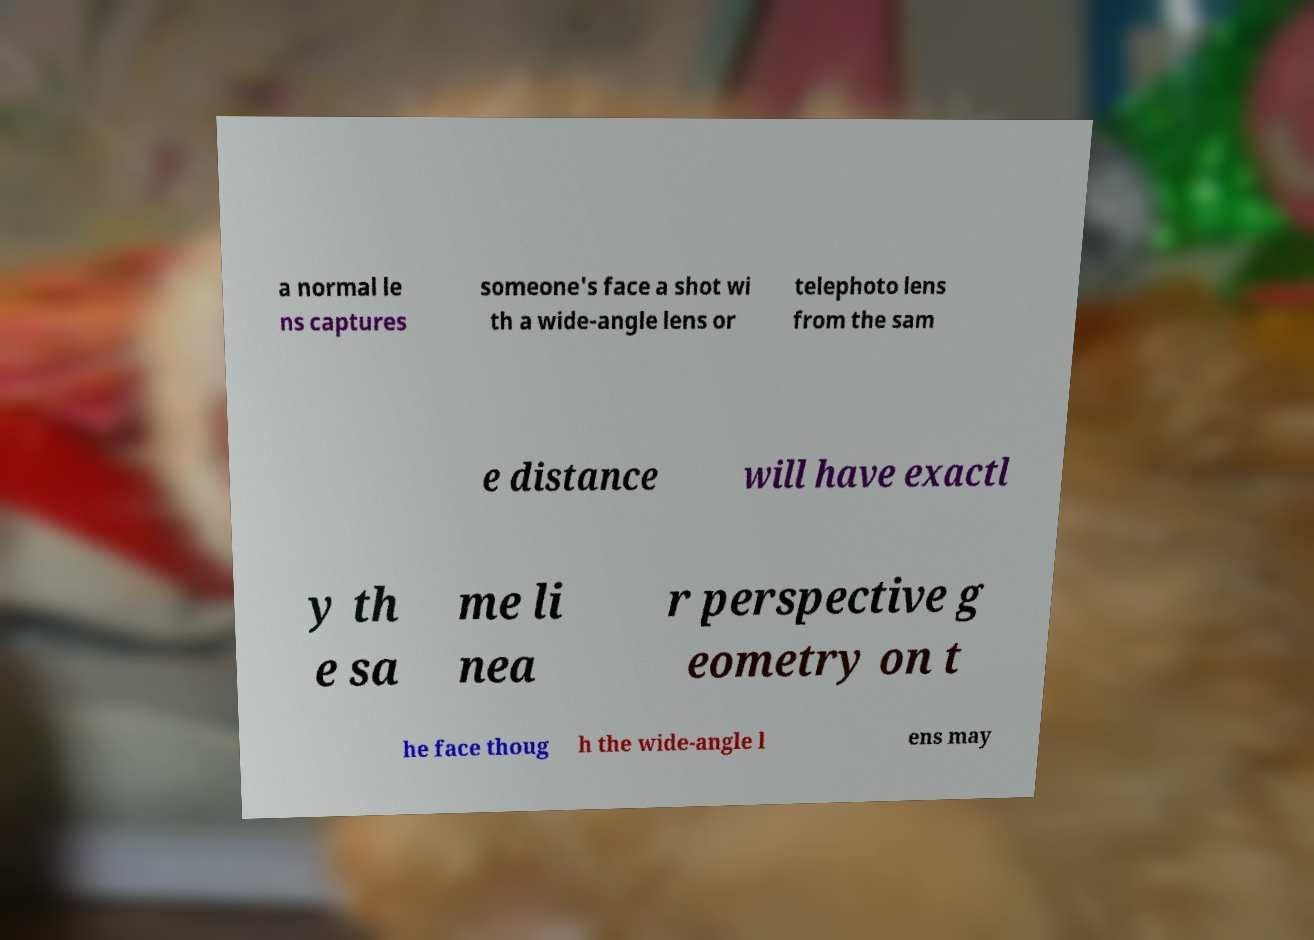Could you extract and type out the text from this image? a normal le ns captures someone's face a shot wi th a wide-angle lens or telephoto lens from the sam e distance will have exactl y th e sa me li nea r perspective g eometry on t he face thoug h the wide-angle l ens may 